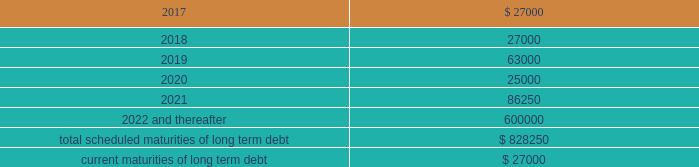Be adjusted by reference to a grid ( the 201cpricing grid 201d ) based on the consolidated leverage ratio and ranges between 1.00% ( 1.00 % ) to 1.25% ( 1.25 % ) for adjusted libor loans and 0.00% ( 0.00 % ) to 0.25% ( 0.25 % ) for alternate base rate loans .
The weighted average interest rate under the outstanding term loans and revolving credit facility borrowings was 1.6% ( 1.6 % ) and 1.3% ( 1.3 % ) during the years ended december 31 , 2016 and 2015 , respectively .
The company pays a commitment fee on the average daily unused amount of the revolving credit facility and certain fees with respect to letters of credit .
As of december 31 , 2016 , the commitment fee was 15.0 basis points .
Since inception , the company incurred and deferred $ 3.9 million in financing costs in connection with the credit agreement .
3.250% ( 3.250 % ) senior notes in june 2016 , the company issued $ 600.0 million aggregate principal amount of 3.250% ( 3.250 % ) senior unsecured notes due june 15 , 2026 ( the 201cnotes 201d ) .
The proceeds were used to pay down amounts outstanding under the revolving credit facility .
Interest is payable semi-annually on june 15 and december 15 beginning december 15 , 2016 .
Prior to march 15 , 2026 ( three months prior to the maturity date of the notes ) , the company may redeem some or all of the notes at any time or from time to time at a redemption price equal to the greater of 100% ( 100 % ) of the principal amount of the notes to be redeemed or a 201cmake-whole 201d amount applicable to such notes as described in the indenture governing the notes , plus accrued and unpaid interest to , but excluding , the redemption date .
On or after march 15 , 2026 ( three months prior to the maturity date of the notes ) , the company may redeem some or all of the notes at any time or from time to time at a redemption price equal to 100% ( 100 % ) of the principal amount of the notes to be redeemed , plus accrued and unpaid interest to , but excluding , the redemption date .
The indenture governing the notes contains covenants , including limitations that restrict the company 2019s ability and the ability of certain of its subsidiaries to create or incur secured indebtedness and enter into sale and leaseback transactions and the company 2019s ability to consolidate , merge or transfer all or substantially all of its properties or assets to another person , in each case subject to material exceptions described in the indenture .
The company incurred and deferred $ 5.3 million in financing costs in connection with the notes .
Other long term debt in december 2012 , the company entered into a $ 50.0 million recourse loan collateralized by the land , buildings and tenant improvements comprising the company 2019s corporate headquarters .
The loan has a seven year term and maturity date of december 2019 .
The loan bears interest at one month libor plus a margin of 1.50% ( 1.50 % ) , and allows for prepayment without penalty .
The loan includes covenants and events of default substantially consistent with the company 2019s credit agreement discussed above .
The loan also requires prior approval of the lender for certain matters related to the property , including transfers of any interest in the property .
As of december 31 , 2016 and 2015 , the outstanding balance on the loan was $ 42.0 million and $ 44.0 million , respectively .
The weighted average interest rate on the loan was 2.0% ( 2.0 % ) and 1.7% ( 1.7 % ) for the years ended december 31 , 2016 and 2015 , respectively .
The following are the scheduled maturities of long term debt as of december 31 , 2016 : ( in thousands ) .

What is the interest expense based on the average outstanding loan balance in 2016? 
Computations: ((((42.0 + 44.0) / 3) * 2.0%) * 100000)
Answer: 57333.33333. 